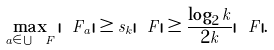Convert formula to latex. <formula><loc_0><loc_0><loc_500><loc_500>\max _ { a \in \bigcup { \ F } } { | \ F _ { a } | } \geq s _ { k } | \ F | \geq \frac { \log _ { 2 } { k } } { 2 k } | \ F | .</formula> 